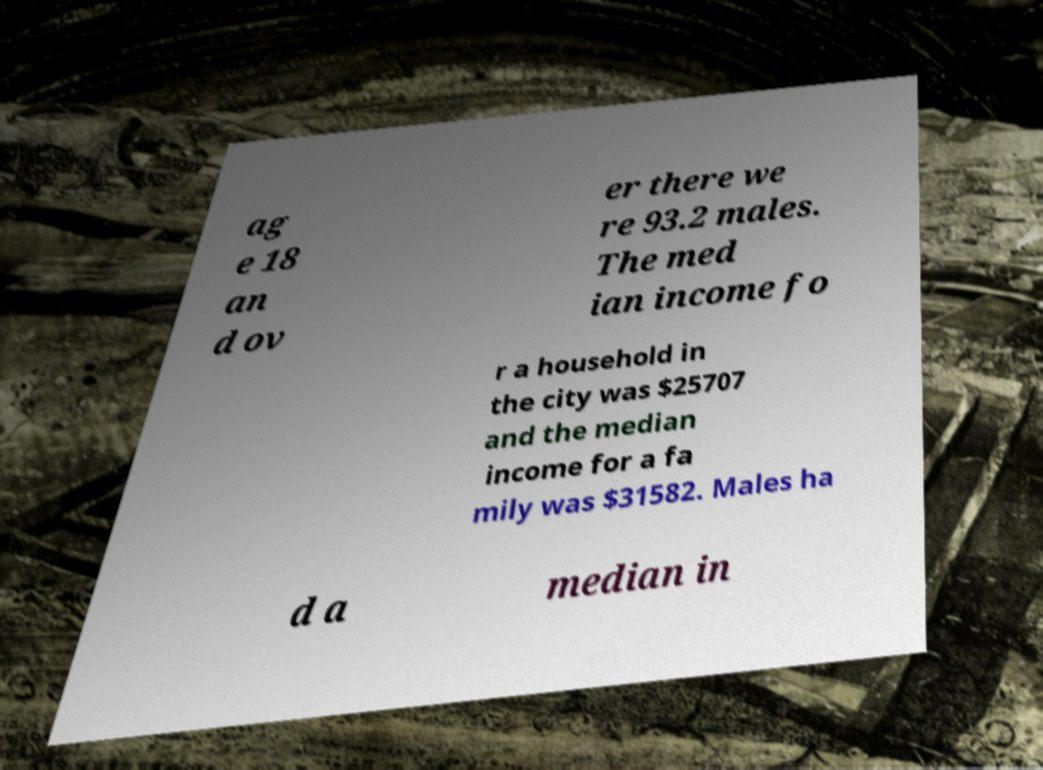I need the written content from this picture converted into text. Can you do that? ag e 18 an d ov er there we re 93.2 males. The med ian income fo r a household in the city was $25707 and the median income for a fa mily was $31582. Males ha d a median in 